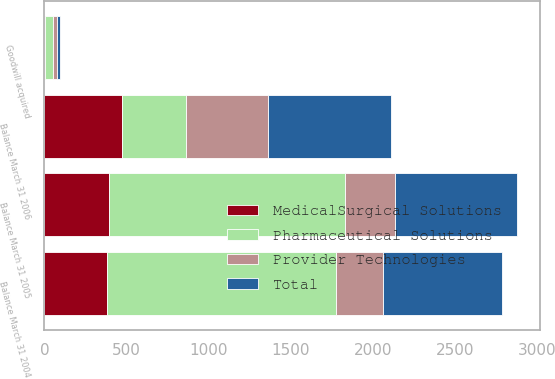Convert chart to OTSL. <chart><loc_0><loc_0><loc_500><loc_500><stacked_bar_chart><ecel><fcel>Balance March 31 2004<fcel>Goodwill acquired<fcel>Balance March 31 2005<fcel>Balance March 31 2006<nl><fcel>Provider Technologies<fcel>285<fcel>24<fcel>300<fcel>497<nl><fcel>Total<fcel>725<fcel>19<fcel>744<fcel>751<nl><fcel>MedicalSurgical Solutions<fcel>383<fcel>4<fcel>395<fcel>470<nl><fcel>Pharmaceutical Solutions<fcel>1393<fcel>47<fcel>1439<fcel>395<nl></chart> 